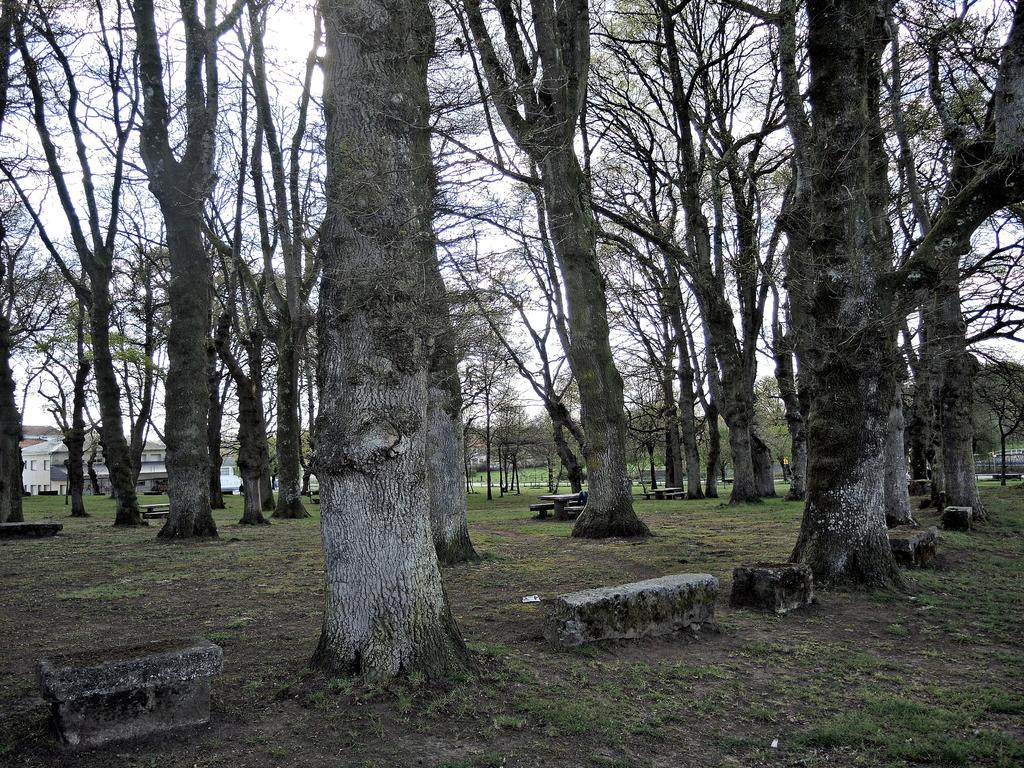What type of vegetation can be seen in the image? There are trees and grass in the image. What type of structures are present in the image? There are buildings in the image. What type of seating is available in the image? There are rock benches in the image. What is visible in the sky in the image? Clouds are visible in the sky in the image. What color is the bee's hair in the image? There is no bee present in the image, and therefore no hair to describe. 